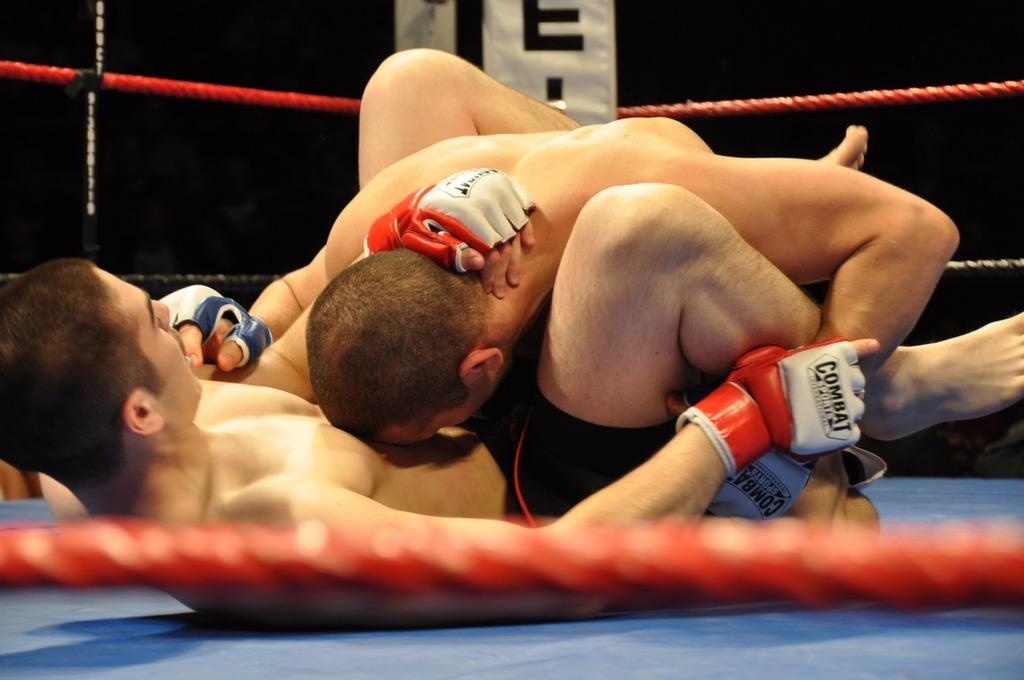How many people are in the image? There are two men in the image. What are the men doing in the image? The men are fighting in the image. Where is the fighting taking place? The fighting is taking place inside a wrestling ring. What can be observed about the lighting in the image? The background of the image is dark. What type of spark can be seen coming from the visitor in the image? There is no visitor present in the image, and therefore no spark can be observed. 